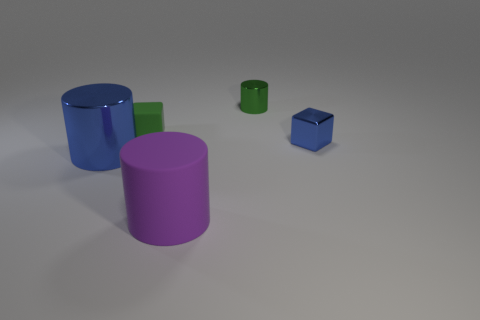What material is the tiny block that is the same color as the large metallic cylinder?
Keep it short and to the point. Metal. The green metal thing that is the same shape as the purple thing is what size?
Ensure brevity in your answer.  Small. Are there any other things that are the same material as the purple thing?
Keep it short and to the point. Yes. There is a small rubber thing; what shape is it?
Give a very brief answer. Cube. The blue thing that is the same size as the purple matte cylinder is what shape?
Provide a short and direct response. Cylinder. Is there anything else that is the same color as the metal block?
Keep it short and to the point. Yes. What size is the cube that is made of the same material as the big blue object?
Offer a terse response. Small. Does the green metal thing have the same shape as the blue thing that is on the right side of the big purple rubber object?
Your answer should be very brief. No. What size is the purple object?
Give a very brief answer. Large. Are there fewer metallic cubes in front of the blue cube than large metallic cylinders?
Make the answer very short. Yes. 